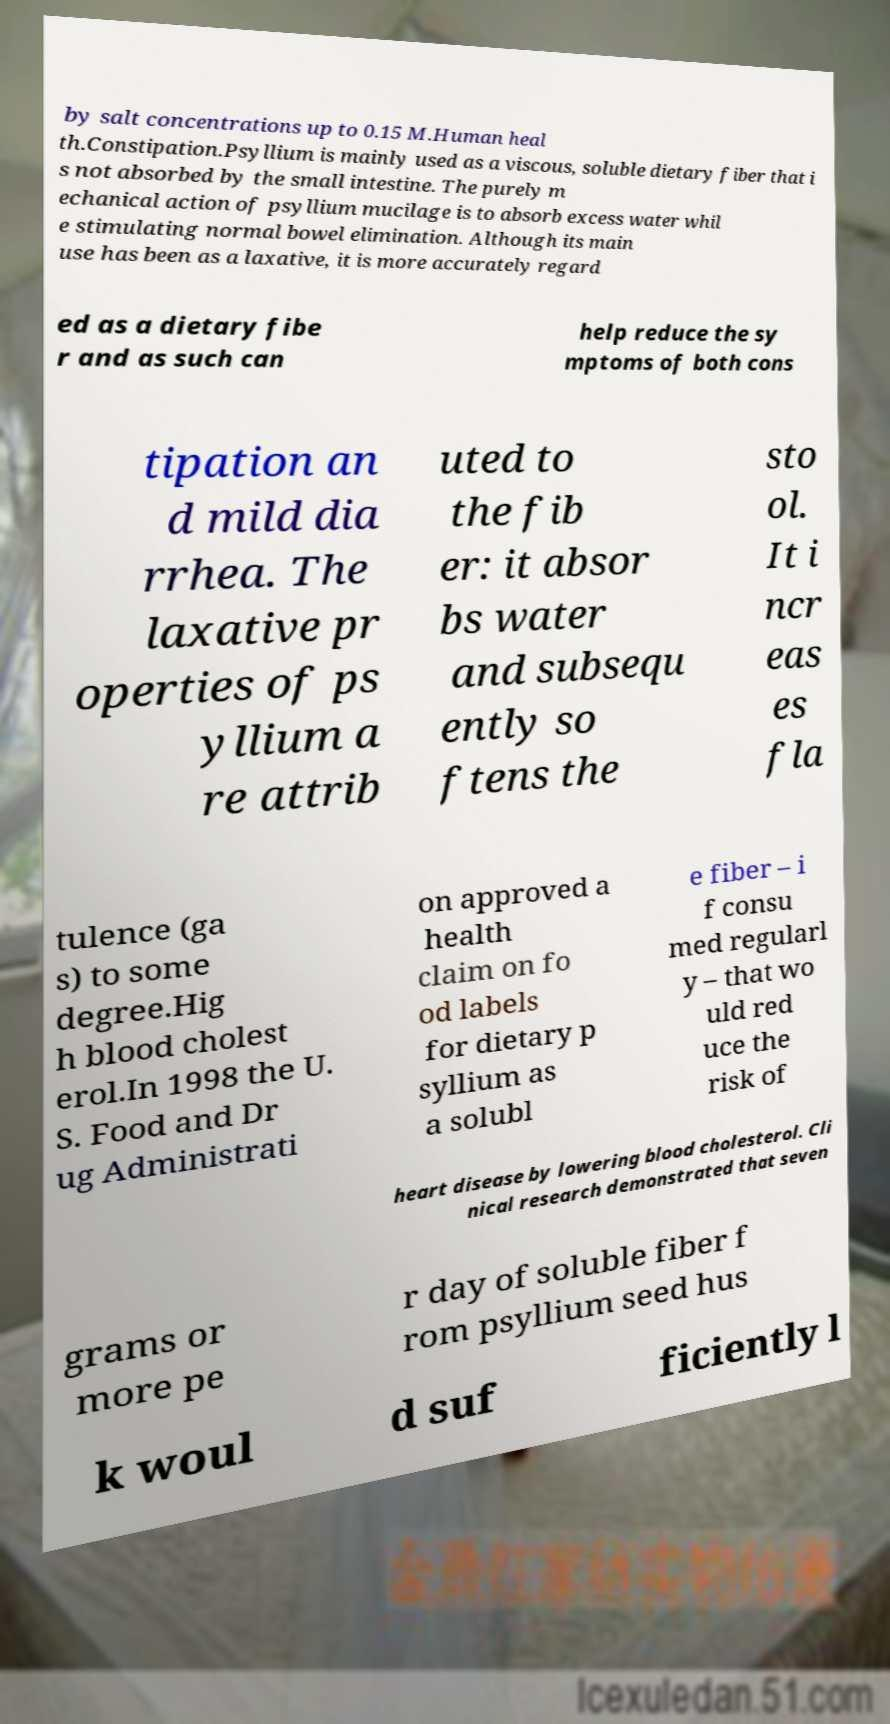There's text embedded in this image that I need extracted. Can you transcribe it verbatim? by salt concentrations up to 0.15 M.Human heal th.Constipation.Psyllium is mainly used as a viscous, soluble dietary fiber that i s not absorbed by the small intestine. The purely m echanical action of psyllium mucilage is to absorb excess water whil e stimulating normal bowel elimination. Although its main use has been as a laxative, it is more accurately regard ed as a dietary fibe r and as such can help reduce the sy mptoms of both cons tipation an d mild dia rrhea. The laxative pr operties of ps yllium a re attrib uted to the fib er: it absor bs water and subsequ ently so ftens the sto ol. It i ncr eas es fla tulence (ga s) to some degree.Hig h blood cholest erol.In 1998 the U. S. Food and Dr ug Administrati on approved a health claim on fo od labels for dietary p syllium as a solubl e fiber – i f consu med regularl y – that wo uld red uce the risk of heart disease by lowering blood cholesterol. Cli nical research demonstrated that seven grams or more pe r day of soluble fiber f rom psyllium seed hus k woul d suf ficiently l 